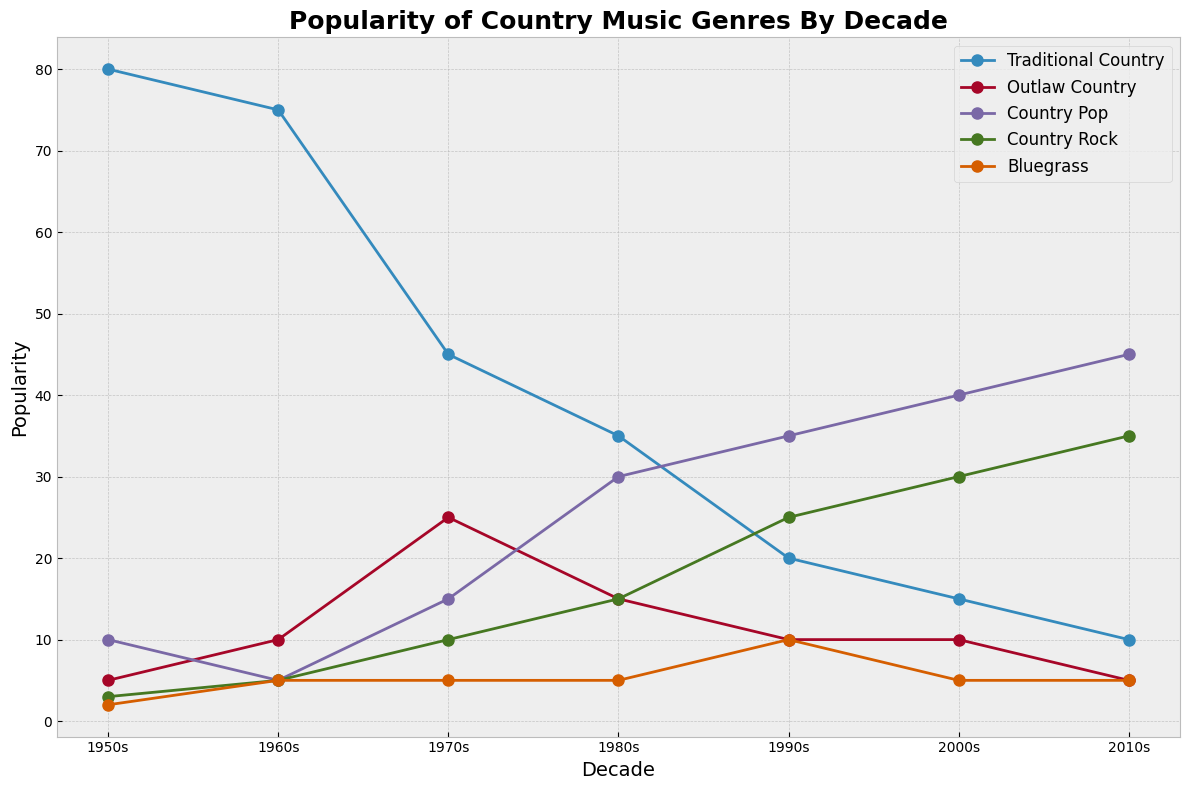What is the most popular genre in the 2010s? According to the plot, the genre with the highest popularity in the 2010s is Country Pop.
Answer: Country Pop What genre saw the biggest increase in popularity from the 1950s to the 2010s? Comparing the values from the 1950s and the 2010s, Country Pop increased from 10% in the 1950s to 45% in the 2010s, which is the biggest increase among all genres.
Answer: Country Pop Which genre was the least popular in the 1950s? Referring to the plot, Bluegrass had the lowest popularity in the 1950s at 2%.
Answer: Bluegrass How did the popularity of Traditional Country change over the decades? Traditional Country decreased from 80% in the 1950s to 10% in the 2010s. By looking at the plot, we notice a steady decline each decade: 80% (1950s), 75% (1960s), 45% (1970s), 35% (1980s), 20% (1990s), 15% (2000s), and 10% (2010s).
Answer: It steadily declined Which decades had an equal popularity for Bluegrass and Traditional Country? In the 1960s and 1970s, Bluegrass and Traditional Country both had the same popularity (5% each in the 1960s and 5% each in the 1970s).
Answer: 1960s and 1970s What is the sum of Country Pop's popularity from the 1950s to the 2010s? Adding the values decade by decade: 10 (1950s) + 5 (1960s) + 15 (1970s) + 30 (1980s) + 35 (1990s) + 40 (2000s) + 45 (2010s) results in a total of 180.
Answer: 180 Graphically, which genre has the most consistent popularity across all decades? By observing the plot, Bluegrass's line stays mostly flat and consistent, indicating its popularity remained around 5% across decades.
Answer: Bluegrass In which decades did Outlaw Country see a peak or low in its popularity? Referring to the plot, Outlaw Country peaked in popularity in the 1970s with 25%. It saw its lowest popularity in the 1950s and 2010s, both at 5%.
Answer: 1970s (peak), 1950s and 2010s (low) Compare the popularity of Country Rock and Country Pop in the 1990s. Which one was higher, and by how much? Country Pop had a popularity of 35% in the 1990s, while Country Rock had 25%. So, Country Pop was higher by 10%.
Answer: Country Pop by 10% 